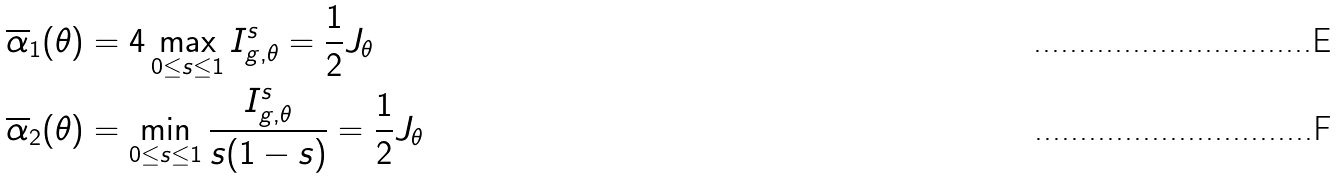Convert formula to latex. <formula><loc_0><loc_0><loc_500><loc_500>\overline { \alpha } _ { 1 } ( \theta ) & = 4 \max _ { 0 \leq s \leq 1 } I ^ { s } _ { g , \theta } = \frac { 1 } { 2 } J _ { \theta } \\ \overline { \alpha } _ { 2 } ( \theta ) & = \min _ { 0 \leq s \leq 1 } \frac { I ^ { s } _ { g , \theta } } { s ( 1 - s ) } = \frac { 1 } { 2 } J _ { \theta }</formula> 